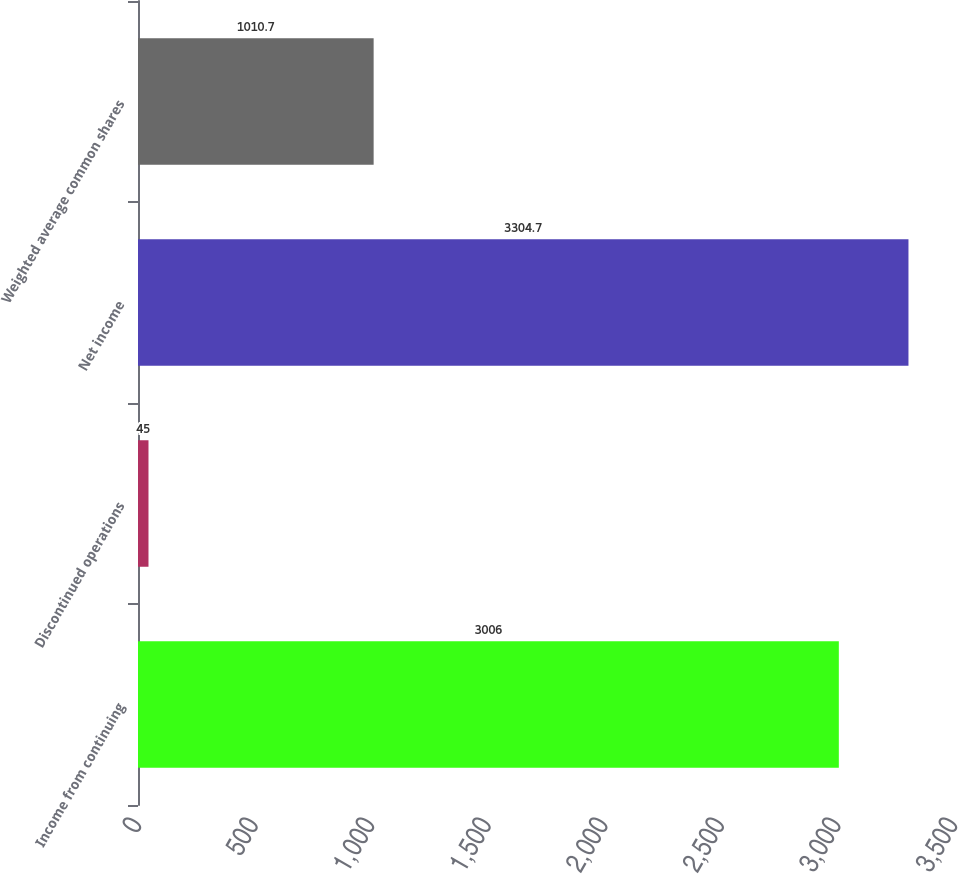Convert chart to OTSL. <chart><loc_0><loc_0><loc_500><loc_500><bar_chart><fcel>Income from continuing<fcel>Discontinued operations<fcel>Net income<fcel>Weighted average common shares<nl><fcel>3006<fcel>45<fcel>3304.7<fcel>1010.7<nl></chart> 